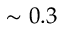Convert formula to latex. <formula><loc_0><loc_0><loc_500><loc_500>\sim 0 . 3</formula> 